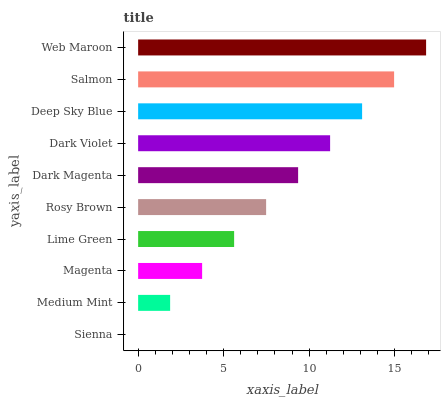Is Sienna the minimum?
Answer yes or no. Yes. Is Web Maroon the maximum?
Answer yes or no. Yes. Is Medium Mint the minimum?
Answer yes or no. No. Is Medium Mint the maximum?
Answer yes or no. No. Is Medium Mint greater than Sienna?
Answer yes or no. Yes. Is Sienna less than Medium Mint?
Answer yes or no. Yes. Is Sienna greater than Medium Mint?
Answer yes or no. No. Is Medium Mint less than Sienna?
Answer yes or no. No. Is Dark Magenta the high median?
Answer yes or no. Yes. Is Rosy Brown the low median?
Answer yes or no. Yes. Is Web Maroon the high median?
Answer yes or no. No. Is Dark Magenta the low median?
Answer yes or no. No. 